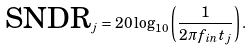Convert formula to latex. <formula><loc_0><loc_0><loc_500><loc_500>\text {SNDR} _ { j } = 2 0 \log _ { 1 0 } \left ( \frac { 1 } { 2 \pi f _ { i n } t _ { j } } \right ) .</formula> 